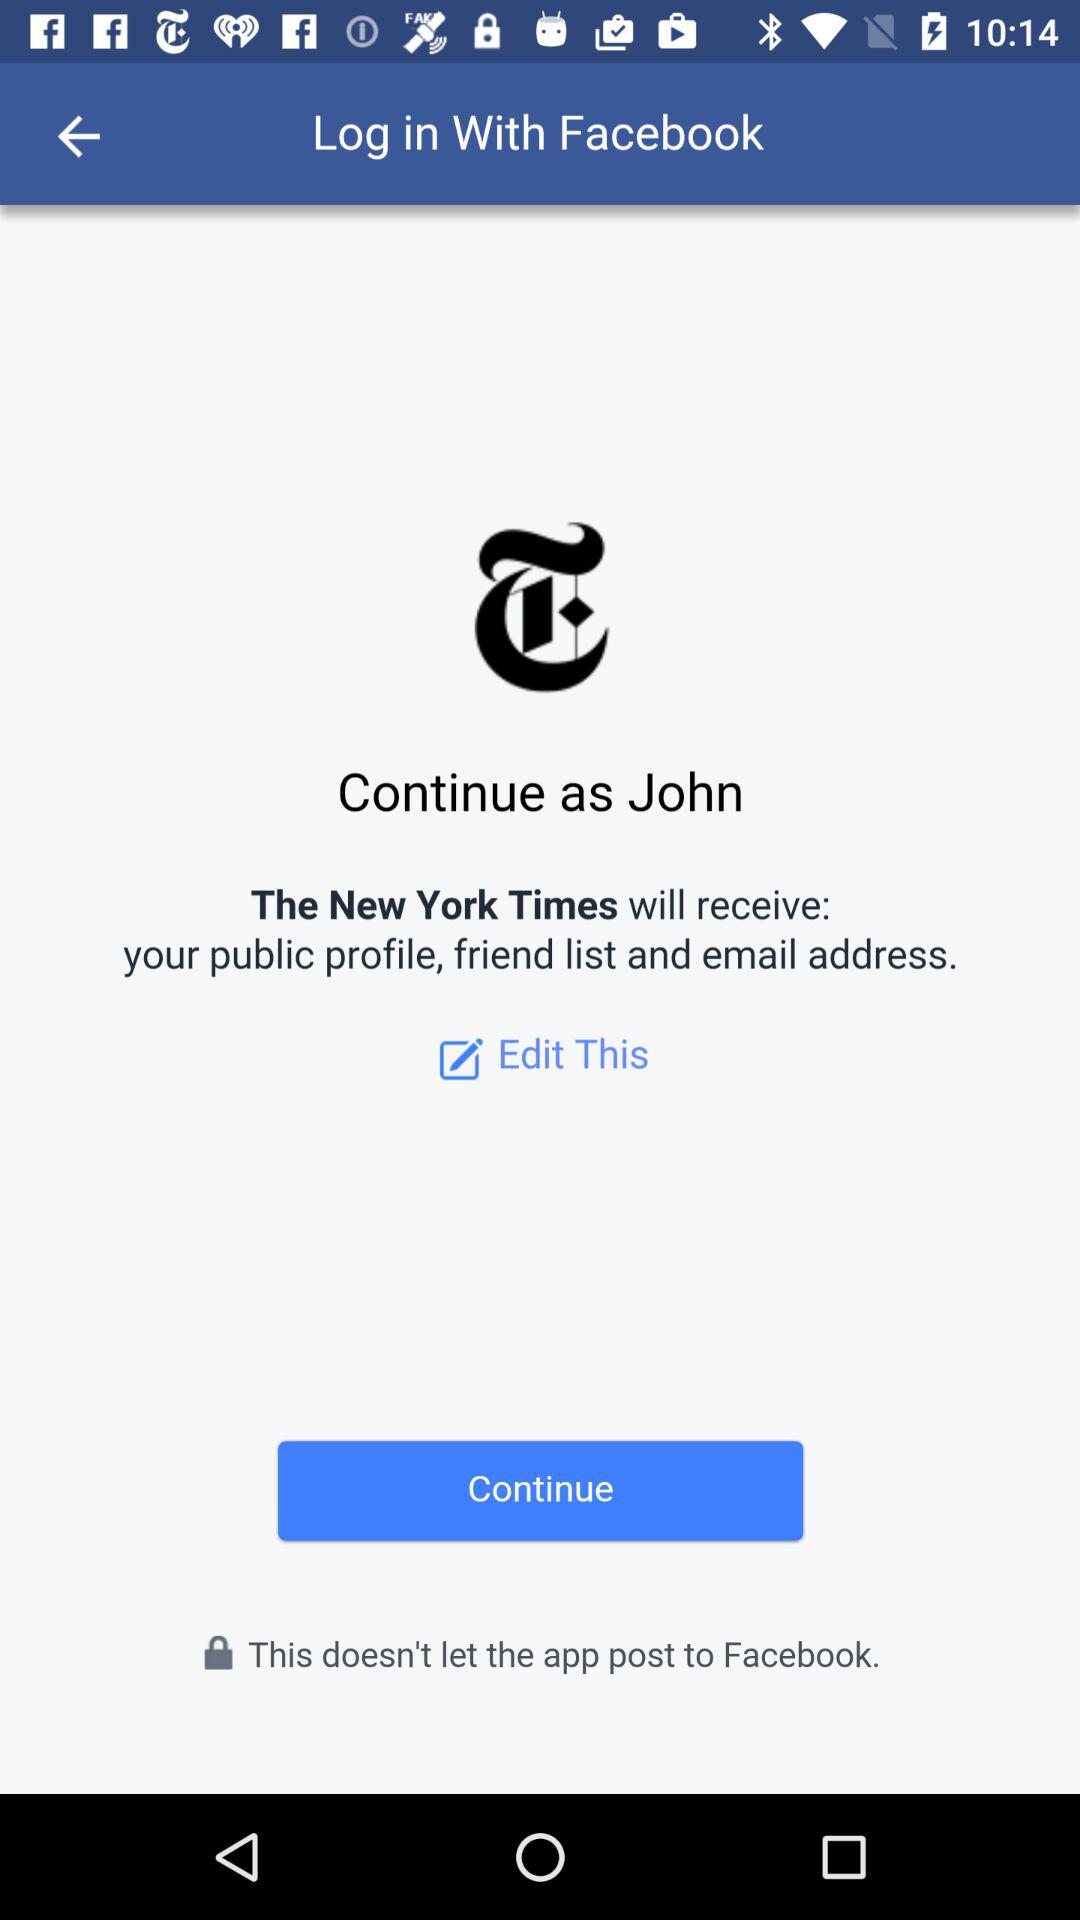What is the name of the user? The name of the user is John. 